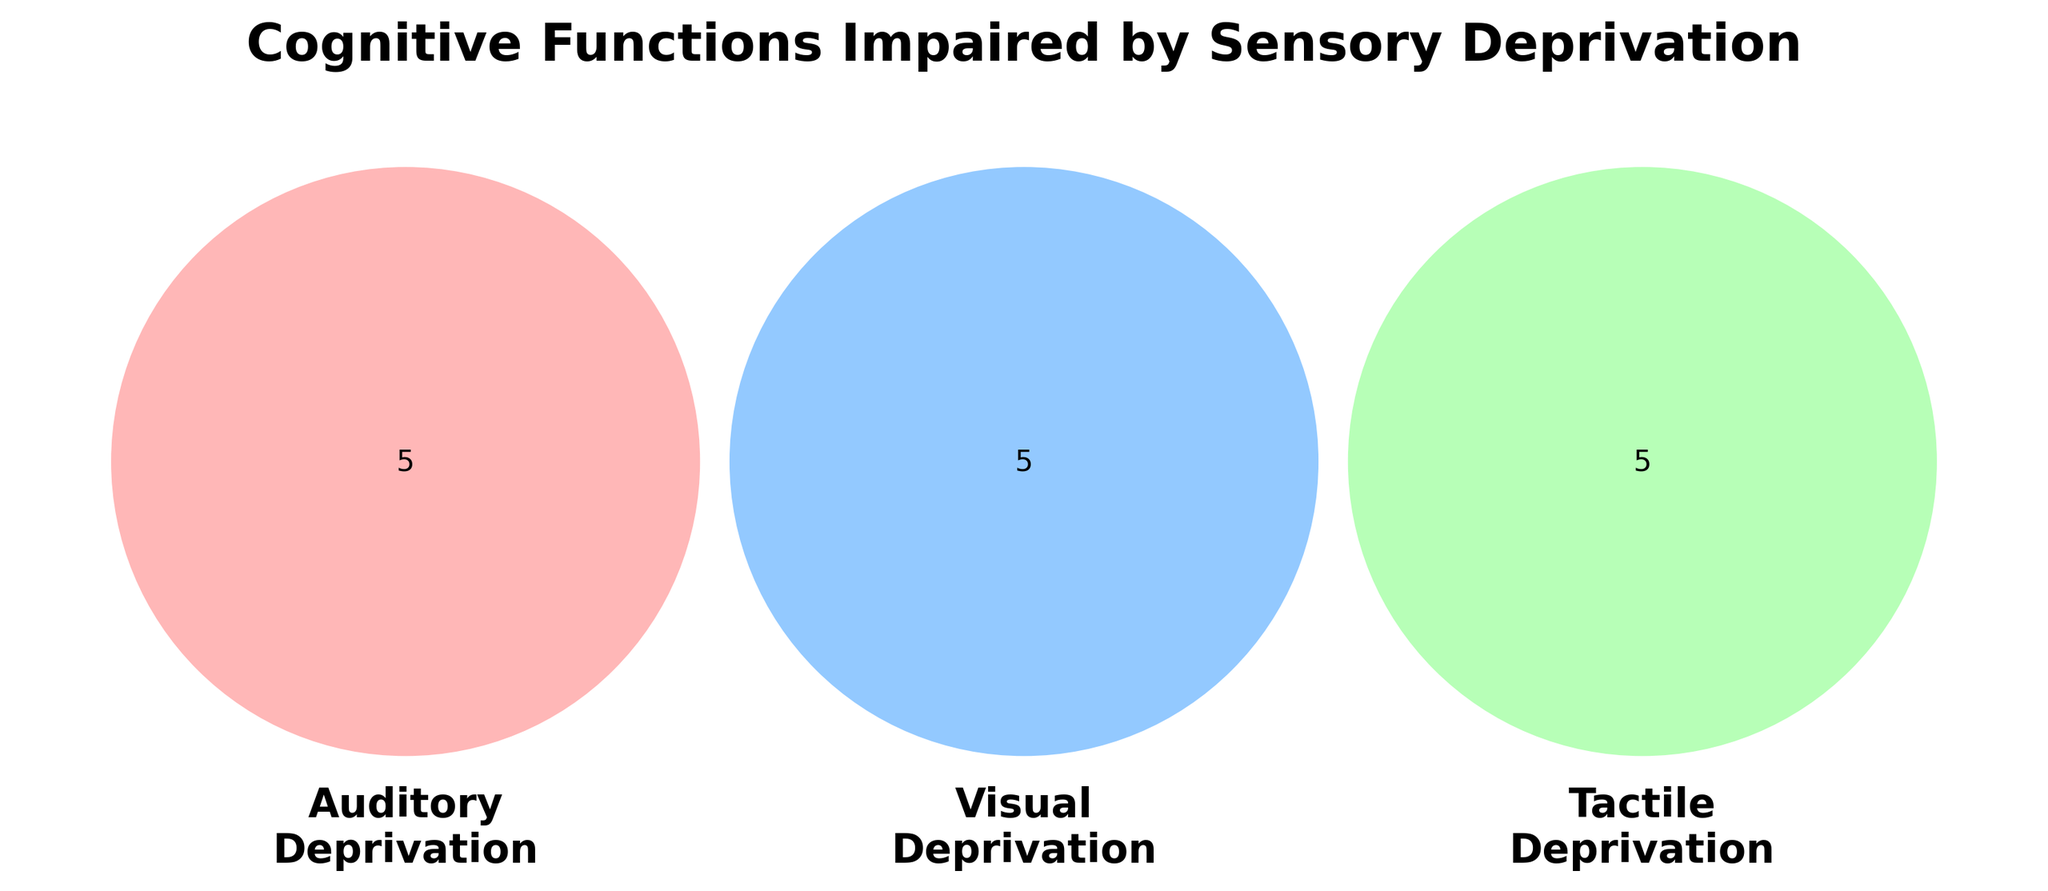What is the title of the Venn Diagram? The figure's title is displayed prominently at the top.
Answer: Cognitive Functions Impaired by Sensory Deprivation Which sensory deprivation impacts speech perception? Observing the Venn sections, "Speech perception" is present only in the 'Auditory Deprivation' circle.
Answer: Auditory deprivation How many cognitive functions are impaired solely by visual deprivation? Count the items in the ‘Visual Deprivation’ circle that do not overlap with others.
Answer: 5 Which sensory deprivation affects tactile discrimination abilities? Review the terms in the 'Tactile Deprivation' circle for relevant functions.
Answer: Tactile deprivation Does any cognitive function overlap between auditory and tactile deprivation? Check the overlapping section between Auditory and Tactile Deprivation circles.
Answer: No What cognitive function is common to both auditory and visual deprivation? Identify the overlapping section between 'Auditory Deprivation' and 'Visual Deprivation'.
Answer: None How many unique cognitive functions are impaired by tactile deprivation? Count all items within tactile deprivation’s individual and overlapping sections.
Answer: 5 Which has more unique impairments: auditory or visual deprivation? Compare the count of unique items in the auditory and visual sections.
Answer: Visual deprivation Is 'depth perception' influenced by auditory deprivation? Locate 'depth perception' and observe if it resides within the 'Auditory Deprivation' circle.
Answer: No What functions are exclusively affected by auditory deprivation? List items only in the Auditory Deprivation circle, not overlapping with others.
Answer: Speech perception, Sound localization, Auditory memory, Tonal discrimination, Temporal processing 